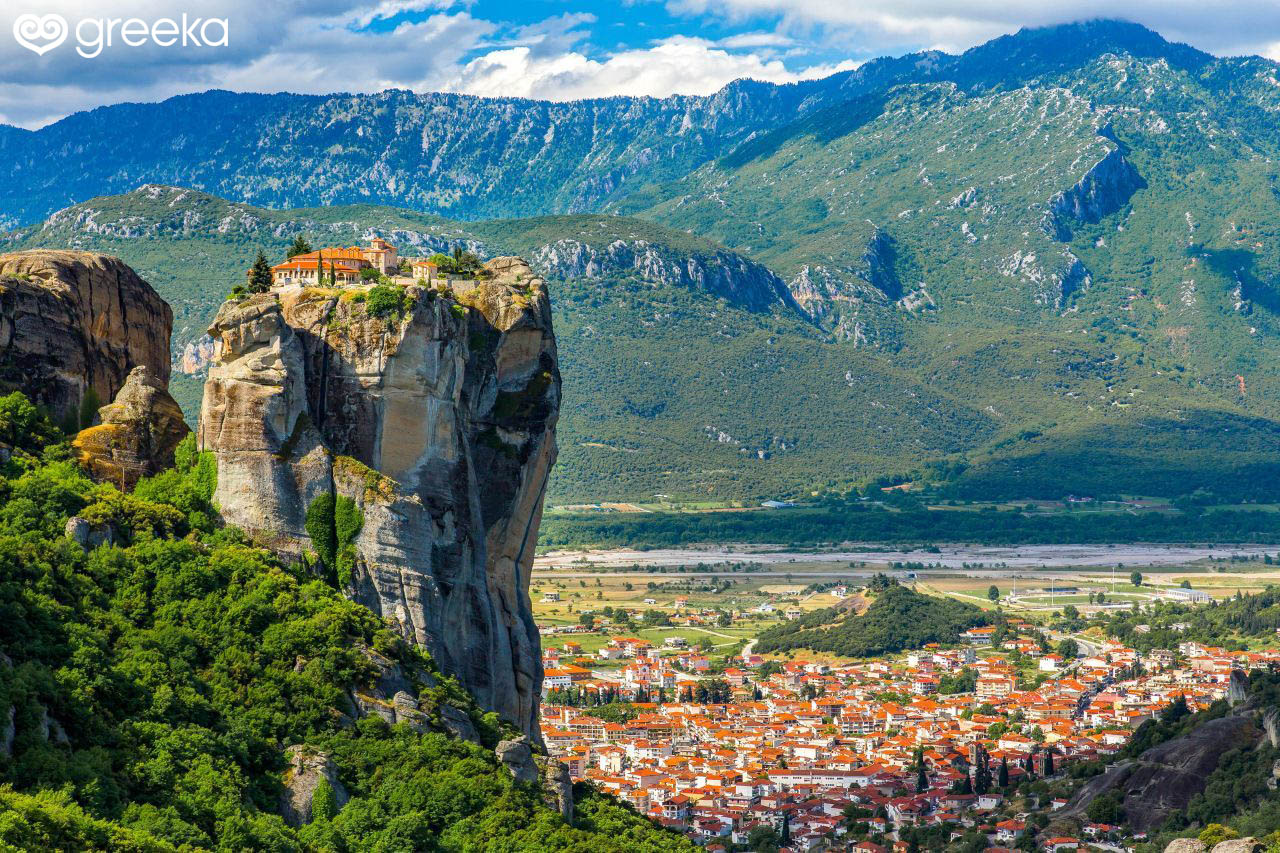How do seasonal changes affect the scenery of Meteora? Seasonal changes bring a dynamic beauty to Meteora, transforming the scenery with each shift. In spring, the landscape bursts into life with verdant vegetation and colorful wildflowers dotting the cliffs and valleys. The air is fresh and the temperatures are mild, making it ideal for exploration. Summer brings warmer weather, during which the hillsides can turn a golden hue, contrasting with the green patches that remain. Autumn paints the area with shades of red, orange, and yellow, adding a rich, warm palette to the view. Winter, although cold, can be particularly magical with occasional snow dusting the rock tops and monastery roofs, creating a serene, almost mystical atmosphere. Each season highlights different aspects of Meteora’s natural beauty, making it a year-round spectacle. How would a thunderstorm look amidst the rock formations of Meteora? Amidst the rock formations of Meteora, a thunderstorm would be a dramatic and awe-inspiring sight. Dark, stormy clouds would gather, casting deep shadows over the landscape and obscuring the mountains in the distance. Lightning would intermittently illuminate the sky, highlighting the sheer cliffs and the monastery perched atop them in stark contrast. The thunder would echo through the valleys, adding a resonant soundtrack to the visual spectacle. As rain begins to pour, the view could become shrouded in mist, adding an ethereal quality to the already formidable scene. Such a storm would accentuate the raw power and majesty of Meteora’s natural setting. 